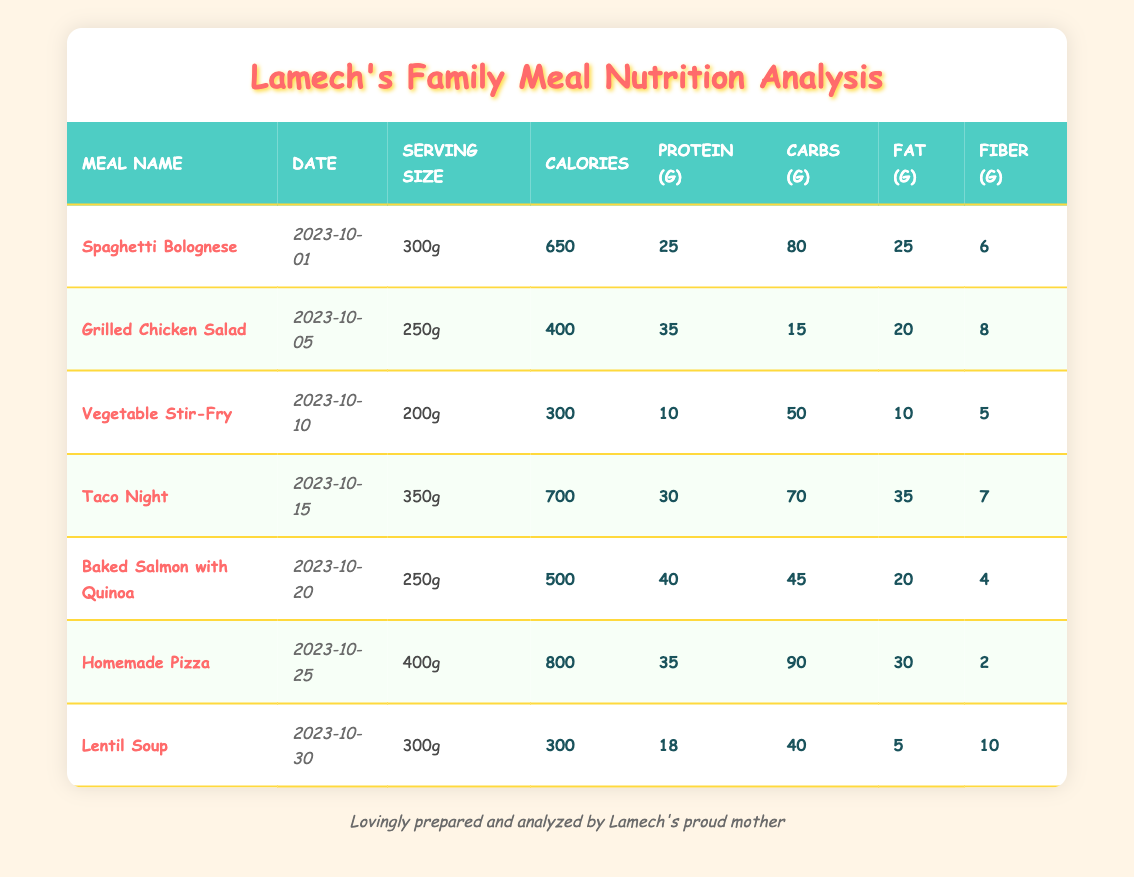What is the meal with the highest calories? To find the meal with the highest calories, I will scan through the 'Calories' column in the table. The meals and their calorie counts are: Spaghetti Bolognese (650), Grilled Chicken Salad (400), Vegetable Stir-Fry (300), Taco Night (700), Baked Salmon with Quinoa (500), Homemade Pizza (800), and Lentil Soup (300). The highest value is 800, which corresponds to Homemade Pizza.
Answer: Homemade Pizza How much protein does Taco Night have? Taco Night's protein content can be directly found in the table under the 'Protein' column. The value listed for Taco Night is 30 grams of protein.
Answer: 30 grams What is the average carbohydrate content for the meals listed? To calculate the average carbohydrate content, I will sum up the carbohydrate values for all meals: 80 + 15 + 50 + 70 + 45 + 90 + 40 = 390. There are a total of 7 meals, so I divide this sum by 7: 390 / 7 ≈ 55.71. Therefore, the average carbohydrate content is approximately 55.71 grams.
Answer: Approximately 55.71 grams Does any meal contain more than 40 grams of fat? I will review the 'Fat' column to check if any meal exceeds 40 grams of fat. The values are: Spaghetti Bolognese (25), Grilled Chicken Salad (20), Vegetable Stir-Fry (10), Taco Night (35), Baked Salmon with Quinoa (20), Homemade Pizza (30), and Lentil Soup (5). None of these values exceed 40 grams, so the statement is false.
Answer: No What meal has the highest fiber content, and what is that amount? To find the meal with the highest fiber content, I will look at the 'Fiber' column. The fiber values for the meals are 6 (Spaghetti Bolognese), 8 (Grilled Chicken Salad), 5 (Vegetable Stir-Fry), 7 (Taco Night), 4 (Baked Salmon with Quinoa), 2 (Homemade Pizza), and 10 (Lentil Soup). The highest fiber content is 10 grams, which is in the Lentil Soup.
Answer: Lentil Soup, 10 grams What is the total calorie intake from all the meals combined? To find the total calorie intake, I will sum the calorie values for all meals: 650 + 400 + 300 + 700 + 500 + 800 + 300 = 3650. Therefore, the total calorie intake for all meals is 3650 calories.
Answer: 3650 calories How many meals were served during the month of October? I will count the entries in the 'meal_name' column and note there are 7 distinct meals listed for the month of October. Each entry represents a unique meal.
Answer: 7 meals Which meal provides the least amount of protein? To determine which meal provides the least amount of protein, I will look at the 'Protein' column values: 25 (Spaghetti Bolognese), 35 (Grilled Chicken Salad), 10 (Vegetable Stir-Fry), 30 (Taco Night), 40 (Baked Salmon with Quinoa), 35 (Homemade Pizza), and 18 (Lentil Soup). The lowest protein value is 10 grams, attributed to the Vegetable Stir-Fry.
Answer: Vegetable Stir-Fry, 10 grams 